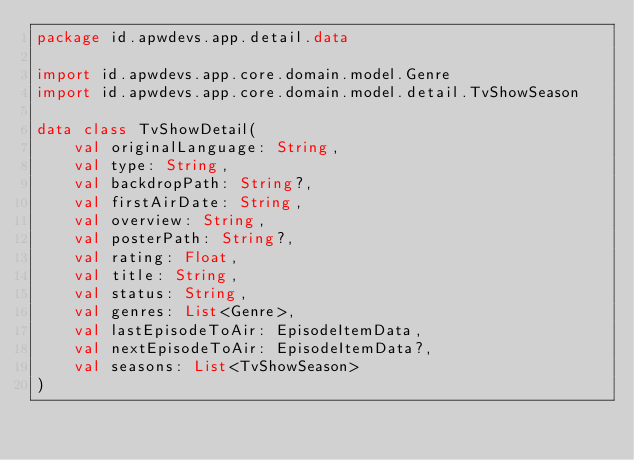<code> <loc_0><loc_0><loc_500><loc_500><_Kotlin_>package id.apwdevs.app.detail.data

import id.apwdevs.app.core.domain.model.Genre
import id.apwdevs.app.core.domain.model.detail.TvShowSeason

data class TvShowDetail(
    val originalLanguage: String,
    val type: String,
    val backdropPath: String?,
    val firstAirDate: String,
    val overview: String,
    val posterPath: String?,
    val rating: Float,
    val title: String,
    val status: String,
    val genres: List<Genre>,
    val lastEpisodeToAir: EpisodeItemData,
    val nextEpisodeToAir: EpisodeItemData?,
    val seasons: List<TvShowSeason>
)</code> 